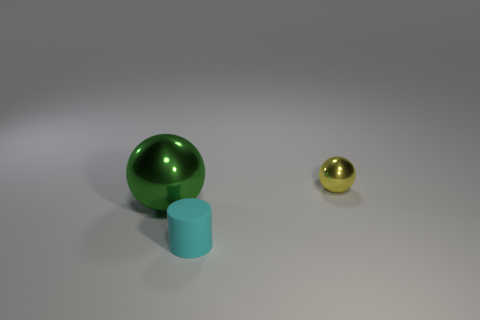Add 2 small yellow rubber cubes. How many objects exist? 5 Subtract all spheres. How many objects are left? 1 Subtract 2 balls. How many balls are left? 0 Subtract all blue cylinders. Subtract all brown cubes. How many cylinders are left? 1 Subtract all yellow blocks. How many yellow spheres are left? 1 Subtract all tiny gray rubber cubes. Subtract all metallic balls. How many objects are left? 1 Add 3 large green balls. How many large green balls are left? 4 Add 2 tiny yellow objects. How many tiny yellow objects exist? 3 Subtract all yellow spheres. How many spheres are left? 1 Subtract 0 green blocks. How many objects are left? 3 